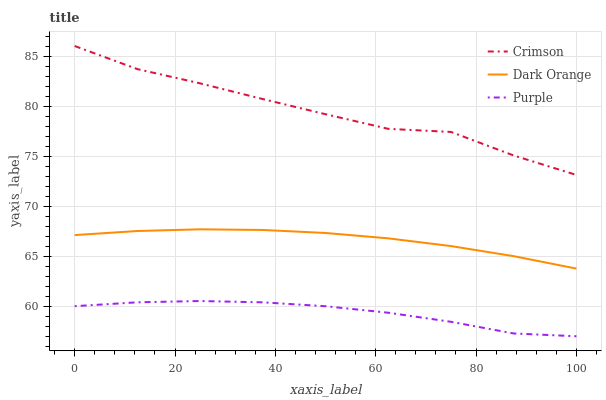Does Purple have the minimum area under the curve?
Answer yes or no. Yes. Does Crimson have the maximum area under the curve?
Answer yes or no. Yes. Does Dark Orange have the minimum area under the curve?
Answer yes or no. No. Does Dark Orange have the maximum area under the curve?
Answer yes or no. No. Is Dark Orange the smoothest?
Answer yes or no. Yes. Is Crimson the roughest?
Answer yes or no. Yes. Is Purple the smoothest?
Answer yes or no. No. Is Purple the roughest?
Answer yes or no. No. Does Purple have the lowest value?
Answer yes or no. Yes. Does Dark Orange have the lowest value?
Answer yes or no. No. Does Crimson have the highest value?
Answer yes or no. Yes. Does Dark Orange have the highest value?
Answer yes or no. No. Is Purple less than Dark Orange?
Answer yes or no. Yes. Is Crimson greater than Dark Orange?
Answer yes or no. Yes. Does Purple intersect Dark Orange?
Answer yes or no. No. 